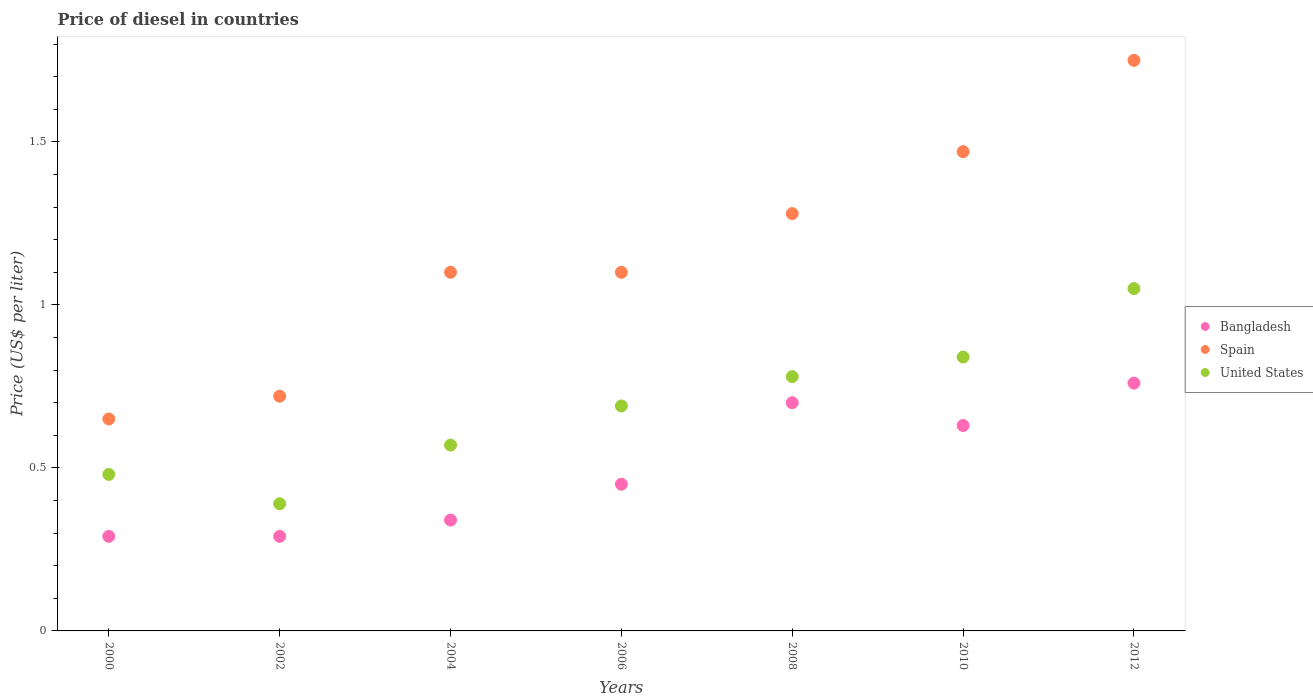What is the price of diesel in United States in 2006?
Provide a succinct answer. 0.69. Across all years, what is the maximum price of diesel in United States?
Provide a succinct answer. 1.05. Across all years, what is the minimum price of diesel in Spain?
Provide a short and direct response. 0.65. In which year was the price of diesel in United States maximum?
Give a very brief answer. 2012. In which year was the price of diesel in Bangladesh minimum?
Offer a terse response. 2000. What is the total price of diesel in Spain in the graph?
Your answer should be very brief. 8.07. What is the difference between the price of diesel in United States in 2002 and that in 2010?
Provide a succinct answer. -0.45. What is the average price of diesel in Bangladesh per year?
Provide a succinct answer. 0.49. In the year 2012, what is the difference between the price of diesel in Bangladesh and price of diesel in United States?
Your answer should be very brief. -0.29. What is the ratio of the price of diesel in Spain in 2006 to that in 2010?
Give a very brief answer. 0.75. Is the price of diesel in United States in 2004 less than that in 2006?
Make the answer very short. Yes. What is the difference between the highest and the second highest price of diesel in United States?
Give a very brief answer. 0.21. What is the difference between the highest and the lowest price of diesel in Bangladesh?
Ensure brevity in your answer.  0.47. In how many years, is the price of diesel in Spain greater than the average price of diesel in Spain taken over all years?
Provide a succinct answer. 3. Is the sum of the price of diesel in United States in 2002 and 2010 greater than the maximum price of diesel in Bangladesh across all years?
Your answer should be compact. Yes. Does the price of diesel in Spain monotonically increase over the years?
Keep it short and to the point. No. How many years are there in the graph?
Ensure brevity in your answer.  7. Are the values on the major ticks of Y-axis written in scientific E-notation?
Provide a short and direct response. No. Does the graph contain any zero values?
Provide a succinct answer. No. Where does the legend appear in the graph?
Your answer should be compact. Center right. How are the legend labels stacked?
Your response must be concise. Vertical. What is the title of the graph?
Give a very brief answer. Price of diesel in countries. Does "St. Lucia" appear as one of the legend labels in the graph?
Give a very brief answer. No. What is the label or title of the Y-axis?
Provide a short and direct response. Price (US$ per liter). What is the Price (US$ per liter) in Bangladesh in 2000?
Give a very brief answer. 0.29. What is the Price (US$ per liter) of Spain in 2000?
Your response must be concise. 0.65. What is the Price (US$ per liter) of United States in 2000?
Offer a terse response. 0.48. What is the Price (US$ per liter) of Bangladesh in 2002?
Give a very brief answer. 0.29. What is the Price (US$ per liter) in Spain in 2002?
Ensure brevity in your answer.  0.72. What is the Price (US$ per liter) of United States in 2002?
Ensure brevity in your answer.  0.39. What is the Price (US$ per liter) in Bangladesh in 2004?
Make the answer very short. 0.34. What is the Price (US$ per liter) of Spain in 2004?
Give a very brief answer. 1.1. What is the Price (US$ per liter) in United States in 2004?
Your answer should be very brief. 0.57. What is the Price (US$ per liter) of Bangladesh in 2006?
Your answer should be compact. 0.45. What is the Price (US$ per liter) of United States in 2006?
Make the answer very short. 0.69. What is the Price (US$ per liter) in Spain in 2008?
Keep it short and to the point. 1.28. What is the Price (US$ per liter) of United States in 2008?
Provide a short and direct response. 0.78. What is the Price (US$ per liter) of Bangladesh in 2010?
Offer a terse response. 0.63. What is the Price (US$ per liter) in Spain in 2010?
Make the answer very short. 1.47. What is the Price (US$ per liter) of United States in 2010?
Your answer should be very brief. 0.84. What is the Price (US$ per liter) of Bangladesh in 2012?
Keep it short and to the point. 0.76. What is the Price (US$ per liter) of Spain in 2012?
Your answer should be very brief. 1.75. Across all years, what is the maximum Price (US$ per liter) in Bangladesh?
Your answer should be very brief. 0.76. Across all years, what is the maximum Price (US$ per liter) in Spain?
Your answer should be compact. 1.75. Across all years, what is the maximum Price (US$ per liter) in United States?
Provide a succinct answer. 1.05. Across all years, what is the minimum Price (US$ per liter) in Bangladesh?
Provide a short and direct response. 0.29. Across all years, what is the minimum Price (US$ per liter) in Spain?
Offer a terse response. 0.65. Across all years, what is the minimum Price (US$ per liter) of United States?
Offer a very short reply. 0.39. What is the total Price (US$ per liter) of Bangladesh in the graph?
Your answer should be compact. 3.46. What is the total Price (US$ per liter) of Spain in the graph?
Offer a terse response. 8.07. What is the total Price (US$ per liter) in United States in the graph?
Offer a terse response. 4.8. What is the difference between the Price (US$ per liter) of Bangladesh in 2000 and that in 2002?
Provide a short and direct response. 0. What is the difference between the Price (US$ per liter) in Spain in 2000 and that in 2002?
Provide a succinct answer. -0.07. What is the difference between the Price (US$ per liter) in United States in 2000 and that in 2002?
Offer a very short reply. 0.09. What is the difference between the Price (US$ per liter) of Bangladesh in 2000 and that in 2004?
Provide a succinct answer. -0.05. What is the difference between the Price (US$ per liter) in Spain in 2000 and that in 2004?
Keep it short and to the point. -0.45. What is the difference between the Price (US$ per liter) in United States in 2000 and that in 2004?
Offer a terse response. -0.09. What is the difference between the Price (US$ per liter) of Bangladesh in 2000 and that in 2006?
Your response must be concise. -0.16. What is the difference between the Price (US$ per liter) of Spain in 2000 and that in 2006?
Your answer should be compact. -0.45. What is the difference between the Price (US$ per liter) in United States in 2000 and that in 2006?
Your answer should be compact. -0.21. What is the difference between the Price (US$ per liter) in Bangladesh in 2000 and that in 2008?
Your answer should be very brief. -0.41. What is the difference between the Price (US$ per liter) of Spain in 2000 and that in 2008?
Your answer should be compact. -0.63. What is the difference between the Price (US$ per liter) of United States in 2000 and that in 2008?
Ensure brevity in your answer.  -0.3. What is the difference between the Price (US$ per liter) of Bangladesh in 2000 and that in 2010?
Your answer should be compact. -0.34. What is the difference between the Price (US$ per liter) in Spain in 2000 and that in 2010?
Offer a terse response. -0.82. What is the difference between the Price (US$ per liter) of United States in 2000 and that in 2010?
Provide a short and direct response. -0.36. What is the difference between the Price (US$ per liter) in Bangladesh in 2000 and that in 2012?
Make the answer very short. -0.47. What is the difference between the Price (US$ per liter) of United States in 2000 and that in 2012?
Provide a short and direct response. -0.57. What is the difference between the Price (US$ per liter) in Spain in 2002 and that in 2004?
Your answer should be compact. -0.38. What is the difference between the Price (US$ per liter) in United States in 2002 and that in 2004?
Make the answer very short. -0.18. What is the difference between the Price (US$ per liter) in Bangladesh in 2002 and that in 2006?
Your answer should be compact. -0.16. What is the difference between the Price (US$ per liter) of Spain in 2002 and that in 2006?
Give a very brief answer. -0.38. What is the difference between the Price (US$ per liter) of United States in 2002 and that in 2006?
Offer a terse response. -0.3. What is the difference between the Price (US$ per liter) in Bangladesh in 2002 and that in 2008?
Your response must be concise. -0.41. What is the difference between the Price (US$ per liter) in Spain in 2002 and that in 2008?
Your answer should be very brief. -0.56. What is the difference between the Price (US$ per liter) of United States in 2002 and that in 2008?
Ensure brevity in your answer.  -0.39. What is the difference between the Price (US$ per liter) in Bangladesh in 2002 and that in 2010?
Provide a short and direct response. -0.34. What is the difference between the Price (US$ per liter) in Spain in 2002 and that in 2010?
Your answer should be very brief. -0.75. What is the difference between the Price (US$ per liter) in United States in 2002 and that in 2010?
Your answer should be compact. -0.45. What is the difference between the Price (US$ per liter) of Bangladesh in 2002 and that in 2012?
Ensure brevity in your answer.  -0.47. What is the difference between the Price (US$ per liter) of Spain in 2002 and that in 2012?
Offer a terse response. -1.03. What is the difference between the Price (US$ per liter) of United States in 2002 and that in 2012?
Your answer should be compact. -0.66. What is the difference between the Price (US$ per liter) of Bangladesh in 2004 and that in 2006?
Your answer should be compact. -0.11. What is the difference between the Price (US$ per liter) in Spain in 2004 and that in 2006?
Your response must be concise. 0. What is the difference between the Price (US$ per liter) in United States in 2004 and that in 2006?
Provide a succinct answer. -0.12. What is the difference between the Price (US$ per liter) of Bangladesh in 2004 and that in 2008?
Your response must be concise. -0.36. What is the difference between the Price (US$ per liter) in Spain in 2004 and that in 2008?
Offer a terse response. -0.18. What is the difference between the Price (US$ per liter) of United States in 2004 and that in 2008?
Provide a short and direct response. -0.21. What is the difference between the Price (US$ per liter) of Bangladesh in 2004 and that in 2010?
Offer a very short reply. -0.29. What is the difference between the Price (US$ per liter) of Spain in 2004 and that in 2010?
Ensure brevity in your answer.  -0.37. What is the difference between the Price (US$ per liter) in United States in 2004 and that in 2010?
Ensure brevity in your answer.  -0.27. What is the difference between the Price (US$ per liter) of Bangladesh in 2004 and that in 2012?
Your response must be concise. -0.42. What is the difference between the Price (US$ per liter) of Spain in 2004 and that in 2012?
Offer a terse response. -0.65. What is the difference between the Price (US$ per liter) in United States in 2004 and that in 2012?
Keep it short and to the point. -0.48. What is the difference between the Price (US$ per liter) of Spain in 2006 and that in 2008?
Your answer should be very brief. -0.18. What is the difference between the Price (US$ per liter) of United States in 2006 and that in 2008?
Keep it short and to the point. -0.09. What is the difference between the Price (US$ per liter) in Bangladesh in 2006 and that in 2010?
Ensure brevity in your answer.  -0.18. What is the difference between the Price (US$ per liter) in Spain in 2006 and that in 2010?
Provide a succinct answer. -0.37. What is the difference between the Price (US$ per liter) in United States in 2006 and that in 2010?
Keep it short and to the point. -0.15. What is the difference between the Price (US$ per liter) of Bangladesh in 2006 and that in 2012?
Provide a short and direct response. -0.31. What is the difference between the Price (US$ per liter) of Spain in 2006 and that in 2012?
Provide a succinct answer. -0.65. What is the difference between the Price (US$ per liter) in United States in 2006 and that in 2012?
Provide a short and direct response. -0.36. What is the difference between the Price (US$ per liter) of Bangladesh in 2008 and that in 2010?
Offer a terse response. 0.07. What is the difference between the Price (US$ per liter) in Spain in 2008 and that in 2010?
Give a very brief answer. -0.19. What is the difference between the Price (US$ per liter) of United States in 2008 and that in 2010?
Provide a succinct answer. -0.06. What is the difference between the Price (US$ per liter) of Bangladesh in 2008 and that in 2012?
Your answer should be compact. -0.06. What is the difference between the Price (US$ per liter) in Spain in 2008 and that in 2012?
Your answer should be compact. -0.47. What is the difference between the Price (US$ per liter) of United States in 2008 and that in 2012?
Make the answer very short. -0.27. What is the difference between the Price (US$ per liter) in Bangladesh in 2010 and that in 2012?
Offer a terse response. -0.13. What is the difference between the Price (US$ per liter) in Spain in 2010 and that in 2012?
Provide a short and direct response. -0.28. What is the difference between the Price (US$ per liter) of United States in 2010 and that in 2012?
Give a very brief answer. -0.21. What is the difference between the Price (US$ per liter) in Bangladesh in 2000 and the Price (US$ per liter) in Spain in 2002?
Keep it short and to the point. -0.43. What is the difference between the Price (US$ per liter) in Spain in 2000 and the Price (US$ per liter) in United States in 2002?
Ensure brevity in your answer.  0.26. What is the difference between the Price (US$ per liter) in Bangladesh in 2000 and the Price (US$ per liter) in Spain in 2004?
Provide a succinct answer. -0.81. What is the difference between the Price (US$ per liter) of Bangladesh in 2000 and the Price (US$ per liter) of United States in 2004?
Give a very brief answer. -0.28. What is the difference between the Price (US$ per liter) in Bangladesh in 2000 and the Price (US$ per liter) in Spain in 2006?
Give a very brief answer. -0.81. What is the difference between the Price (US$ per liter) of Bangladesh in 2000 and the Price (US$ per liter) of United States in 2006?
Your answer should be compact. -0.4. What is the difference between the Price (US$ per liter) of Spain in 2000 and the Price (US$ per liter) of United States in 2006?
Make the answer very short. -0.04. What is the difference between the Price (US$ per liter) in Bangladesh in 2000 and the Price (US$ per liter) in Spain in 2008?
Your answer should be compact. -0.99. What is the difference between the Price (US$ per liter) in Bangladesh in 2000 and the Price (US$ per liter) in United States in 2008?
Offer a very short reply. -0.49. What is the difference between the Price (US$ per liter) of Spain in 2000 and the Price (US$ per liter) of United States in 2008?
Your response must be concise. -0.13. What is the difference between the Price (US$ per liter) in Bangladesh in 2000 and the Price (US$ per liter) in Spain in 2010?
Provide a short and direct response. -1.18. What is the difference between the Price (US$ per liter) in Bangladesh in 2000 and the Price (US$ per liter) in United States in 2010?
Make the answer very short. -0.55. What is the difference between the Price (US$ per liter) of Spain in 2000 and the Price (US$ per liter) of United States in 2010?
Make the answer very short. -0.19. What is the difference between the Price (US$ per liter) in Bangladesh in 2000 and the Price (US$ per liter) in Spain in 2012?
Your answer should be very brief. -1.46. What is the difference between the Price (US$ per liter) of Bangladesh in 2000 and the Price (US$ per liter) of United States in 2012?
Make the answer very short. -0.76. What is the difference between the Price (US$ per liter) of Spain in 2000 and the Price (US$ per liter) of United States in 2012?
Your answer should be compact. -0.4. What is the difference between the Price (US$ per liter) in Bangladesh in 2002 and the Price (US$ per liter) in Spain in 2004?
Ensure brevity in your answer.  -0.81. What is the difference between the Price (US$ per liter) in Bangladesh in 2002 and the Price (US$ per liter) in United States in 2004?
Offer a terse response. -0.28. What is the difference between the Price (US$ per liter) in Bangladesh in 2002 and the Price (US$ per liter) in Spain in 2006?
Provide a short and direct response. -0.81. What is the difference between the Price (US$ per liter) in Bangladesh in 2002 and the Price (US$ per liter) in Spain in 2008?
Provide a succinct answer. -0.99. What is the difference between the Price (US$ per liter) of Bangladesh in 2002 and the Price (US$ per liter) of United States in 2008?
Provide a short and direct response. -0.49. What is the difference between the Price (US$ per liter) of Spain in 2002 and the Price (US$ per liter) of United States in 2008?
Your answer should be very brief. -0.06. What is the difference between the Price (US$ per liter) of Bangladesh in 2002 and the Price (US$ per liter) of Spain in 2010?
Keep it short and to the point. -1.18. What is the difference between the Price (US$ per liter) in Bangladesh in 2002 and the Price (US$ per liter) in United States in 2010?
Provide a short and direct response. -0.55. What is the difference between the Price (US$ per liter) in Spain in 2002 and the Price (US$ per liter) in United States in 2010?
Give a very brief answer. -0.12. What is the difference between the Price (US$ per liter) in Bangladesh in 2002 and the Price (US$ per liter) in Spain in 2012?
Ensure brevity in your answer.  -1.46. What is the difference between the Price (US$ per liter) of Bangladesh in 2002 and the Price (US$ per liter) of United States in 2012?
Make the answer very short. -0.76. What is the difference between the Price (US$ per liter) in Spain in 2002 and the Price (US$ per liter) in United States in 2012?
Offer a terse response. -0.33. What is the difference between the Price (US$ per liter) in Bangladesh in 2004 and the Price (US$ per liter) in Spain in 2006?
Your answer should be very brief. -0.76. What is the difference between the Price (US$ per liter) in Bangladesh in 2004 and the Price (US$ per liter) in United States in 2006?
Give a very brief answer. -0.35. What is the difference between the Price (US$ per liter) in Spain in 2004 and the Price (US$ per liter) in United States in 2006?
Keep it short and to the point. 0.41. What is the difference between the Price (US$ per liter) in Bangladesh in 2004 and the Price (US$ per liter) in Spain in 2008?
Keep it short and to the point. -0.94. What is the difference between the Price (US$ per liter) in Bangladesh in 2004 and the Price (US$ per liter) in United States in 2008?
Provide a short and direct response. -0.44. What is the difference between the Price (US$ per liter) in Spain in 2004 and the Price (US$ per liter) in United States in 2008?
Provide a succinct answer. 0.32. What is the difference between the Price (US$ per liter) of Bangladesh in 2004 and the Price (US$ per liter) of Spain in 2010?
Give a very brief answer. -1.13. What is the difference between the Price (US$ per liter) of Bangladesh in 2004 and the Price (US$ per liter) of United States in 2010?
Offer a very short reply. -0.5. What is the difference between the Price (US$ per liter) in Spain in 2004 and the Price (US$ per liter) in United States in 2010?
Your answer should be very brief. 0.26. What is the difference between the Price (US$ per liter) in Bangladesh in 2004 and the Price (US$ per liter) in Spain in 2012?
Ensure brevity in your answer.  -1.41. What is the difference between the Price (US$ per liter) in Bangladesh in 2004 and the Price (US$ per liter) in United States in 2012?
Keep it short and to the point. -0.71. What is the difference between the Price (US$ per liter) in Bangladesh in 2006 and the Price (US$ per liter) in Spain in 2008?
Offer a terse response. -0.83. What is the difference between the Price (US$ per liter) in Bangladesh in 2006 and the Price (US$ per liter) in United States in 2008?
Provide a succinct answer. -0.33. What is the difference between the Price (US$ per liter) of Spain in 2006 and the Price (US$ per liter) of United States in 2008?
Make the answer very short. 0.32. What is the difference between the Price (US$ per liter) of Bangladesh in 2006 and the Price (US$ per liter) of Spain in 2010?
Provide a succinct answer. -1.02. What is the difference between the Price (US$ per liter) in Bangladesh in 2006 and the Price (US$ per liter) in United States in 2010?
Your answer should be compact. -0.39. What is the difference between the Price (US$ per liter) of Spain in 2006 and the Price (US$ per liter) of United States in 2010?
Your answer should be compact. 0.26. What is the difference between the Price (US$ per liter) in Bangladesh in 2006 and the Price (US$ per liter) in United States in 2012?
Your answer should be compact. -0.6. What is the difference between the Price (US$ per liter) of Spain in 2006 and the Price (US$ per liter) of United States in 2012?
Provide a short and direct response. 0.05. What is the difference between the Price (US$ per liter) in Bangladesh in 2008 and the Price (US$ per liter) in Spain in 2010?
Offer a terse response. -0.77. What is the difference between the Price (US$ per liter) in Bangladesh in 2008 and the Price (US$ per liter) in United States in 2010?
Offer a very short reply. -0.14. What is the difference between the Price (US$ per liter) of Spain in 2008 and the Price (US$ per liter) of United States in 2010?
Make the answer very short. 0.44. What is the difference between the Price (US$ per liter) of Bangladesh in 2008 and the Price (US$ per liter) of Spain in 2012?
Make the answer very short. -1.05. What is the difference between the Price (US$ per liter) of Bangladesh in 2008 and the Price (US$ per liter) of United States in 2012?
Make the answer very short. -0.35. What is the difference between the Price (US$ per liter) of Spain in 2008 and the Price (US$ per liter) of United States in 2012?
Make the answer very short. 0.23. What is the difference between the Price (US$ per liter) in Bangladesh in 2010 and the Price (US$ per liter) in Spain in 2012?
Ensure brevity in your answer.  -1.12. What is the difference between the Price (US$ per liter) in Bangladesh in 2010 and the Price (US$ per liter) in United States in 2012?
Make the answer very short. -0.42. What is the difference between the Price (US$ per liter) in Spain in 2010 and the Price (US$ per liter) in United States in 2012?
Provide a succinct answer. 0.42. What is the average Price (US$ per liter) of Bangladesh per year?
Make the answer very short. 0.49. What is the average Price (US$ per liter) of Spain per year?
Your answer should be very brief. 1.15. What is the average Price (US$ per liter) in United States per year?
Provide a succinct answer. 0.69. In the year 2000, what is the difference between the Price (US$ per liter) in Bangladesh and Price (US$ per liter) in Spain?
Keep it short and to the point. -0.36. In the year 2000, what is the difference between the Price (US$ per liter) of Bangladesh and Price (US$ per liter) of United States?
Offer a very short reply. -0.19. In the year 2000, what is the difference between the Price (US$ per liter) of Spain and Price (US$ per liter) of United States?
Ensure brevity in your answer.  0.17. In the year 2002, what is the difference between the Price (US$ per liter) in Bangladesh and Price (US$ per liter) in Spain?
Keep it short and to the point. -0.43. In the year 2002, what is the difference between the Price (US$ per liter) of Spain and Price (US$ per liter) of United States?
Make the answer very short. 0.33. In the year 2004, what is the difference between the Price (US$ per liter) of Bangladesh and Price (US$ per liter) of Spain?
Your answer should be compact. -0.76. In the year 2004, what is the difference between the Price (US$ per liter) of Bangladesh and Price (US$ per liter) of United States?
Offer a terse response. -0.23. In the year 2004, what is the difference between the Price (US$ per liter) in Spain and Price (US$ per liter) in United States?
Give a very brief answer. 0.53. In the year 2006, what is the difference between the Price (US$ per liter) in Bangladesh and Price (US$ per liter) in Spain?
Make the answer very short. -0.65. In the year 2006, what is the difference between the Price (US$ per liter) of Bangladesh and Price (US$ per liter) of United States?
Offer a very short reply. -0.24. In the year 2006, what is the difference between the Price (US$ per liter) of Spain and Price (US$ per liter) of United States?
Provide a succinct answer. 0.41. In the year 2008, what is the difference between the Price (US$ per liter) in Bangladesh and Price (US$ per liter) in Spain?
Offer a very short reply. -0.58. In the year 2008, what is the difference between the Price (US$ per liter) of Bangladesh and Price (US$ per liter) of United States?
Provide a succinct answer. -0.08. In the year 2010, what is the difference between the Price (US$ per liter) in Bangladesh and Price (US$ per liter) in Spain?
Your answer should be compact. -0.84. In the year 2010, what is the difference between the Price (US$ per liter) in Bangladesh and Price (US$ per liter) in United States?
Ensure brevity in your answer.  -0.21. In the year 2010, what is the difference between the Price (US$ per liter) of Spain and Price (US$ per liter) of United States?
Offer a very short reply. 0.63. In the year 2012, what is the difference between the Price (US$ per liter) in Bangladesh and Price (US$ per liter) in Spain?
Provide a short and direct response. -0.99. In the year 2012, what is the difference between the Price (US$ per liter) in Bangladesh and Price (US$ per liter) in United States?
Your answer should be compact. -0.29. What is the ratio of the Price (US$ per liter) in Bangladesh in 2000 to that in 2002?
Provide a short and direct response. 1. What is the ratio of the Price (US$ per liter) of Spain in 2000 to that in 2002?
Give a very brief answer. 0.9. What is the ratio of the Price (US$ per liter) in United States in 2000 to that in 2002?
Offer a terse response. 1.23. What is the ratio of the Price (US$ per liter) of Bangladesh in 2000 to that in 2004?
Ensure brevity in your answer.  0.85. What is the ratio of the Price (US$ per liter) of Spain in 2000 to that in 2004?
Ensure brevity in your answer.  0.59. What is the ratio of the Price (US$ per liter) in United States in 2000 to that in 2004?
Make the answer very short. 0.84. What is the ratio of the Price (US$ per liter) of Bangladesh in 2000 to that in 2006?
Offer a terse response. 0.64. What is the ratio of the Price (US$ per liter) in Spain in 2000 to that in 2006?
Provide a short and direct response. 0.59. What is the ratio of the Price (US$ per liter) of United States in 2000 to that in 2006?
Your answer should be very brief. 0.7. What is the ratio of the Price (US$ per liter) in Bangladesh in 2000 to that in 2008?
Your response must be concise. 0.41. What is the ratio of the Price (US$ per liter) of Spain in 2000 to that in 2008?
Keep it short and to the point. 0.51. What is the ratio of the Price (US$ per liter) of United States in 2000 to that in 2008?
Your answer should be compact. 0.62. What is the ratio of the Price (US$ per liter) of Bangladesh in 2000 to that in 2010?
Provide a succinct answer. 0.46. What is the ratio of the Price (US$ per liter) of Spain in 2000 to that in 2010?
Provide a succinct answer. 0.44. What is the ratio of the Price (US$ per liter) in United States in 2000 to that in 2010?
Your answer should be compact. 0.57. What is the ratio of the Price (US$ per liter) of Bangladesh in 2000 to that in 2012?
Keep it short and to the point. 0.38. What is the ratio of the Price (US$ per liter) of Spain in 2000 to that in 2012?
Make the answer very short. 0.37. What is the ratio of the Price (US$ per liter) of United States in 2000 to that in 2012?
Ensure brevity in your answer.  0.46. What is the ratio of the Price (US$ per liter) of Bangladesh in 2002 to that in 2004?
Offer a terse response. 0.85. What is the ratio of the Price (US$ per liter) of Spain in 2002 to that in 2004?
Your answer should be very brief. 0.65. What is the ratio of the Price (US$ per liter) of United States in 2002 to that in 2004?
Ensure brevity in your answer.  0.68. What is the ratio of the Price (US$ per liter) in Bangladesh in 2002 to that in 2006?
Your answer should be compact. 0.64. What is the ratio of the Price (US$ per liter) of Spain in 2002 to that in 2006?
Make the answer very short. 0.65. What is the ratio of the Price (US$ per liter) of United States in 2002 to that in 2006?
Offer a very short reply. 0.57. What is the ratio of the Price (US$ per liter) of Bangladesh in 2002 to that in 2008?
Offer a terse response. 0.41. What is the ratio of the Price (US$ per liter) of Spain in 2002 to that in 2008?
Provide a short and direct response. 0.56. What is the ratio of the Price (US$ per liter) in United States in 2002 to that in 2008?
Your answer should be compact. 0.5. What is the ratio of the Price (US$ per liter) of Bangladesh in 2002 to that in 2010?
Your answer should be compact. 0.46. What is the ratio of the Price (US$ per liter) in Spain in 2002 to that in 2010?
Ensure brevity in your answer.  0.49. What is the ratio of the Price (US$ per liter) in United States in 2002 to that in 2010?
Provide a short and direct response. 0.46. What is the ratio of the Price (US$ per liter) of Bangladesh in 2002 to that in 2012?
Keep it short and to the point. 0.38. What is the ratio of the Price (US$ per liter) of Spain in 2002 to that in 2012?
Provide a short and direct response. 0.41. What is the ratio of the Price (US$ per liter) in United States in 2002 to that in 2012?
Provide a short and direct response. 0.37. What is the ratio of the Price (US$ per liter) in Bangladesh in 2004 to that in 2006?
Offer a very short reply. 0.76. What is the ratio of the Price (US$ per liter) in Spain in 2004 to that in 2006?
Provide a short and direct response. 1. What is the ratio of the Price (US$ per liter) in United States in 2004 to that in 2006?
Keep it short and to the point. 0.83. What is the ratio of the Price (US$ per liter) of Bangladesh in 2004 to that in 2008?
Make the answer very short. 0.49. What is the ratio of the Price (US$ per liter) in Spain in 2004 to that in 2008?
Give a very brief answer. 0.86. What is the ratio of the Price (US$ per liter) of United States in 2004 to that in 2008?
Make the answer very short. 0.73. What is the ratio of the Price (US$ per liter) of Bangladesh in 2004 to that in 2010?
Provide a succinct answer. 0.54. What is the ratio of the Price (US$ per liter) of Spain in 2004 to that in 2010?
Make the answer very short. 0.75. What is the ratio of the Price (US$ per liter) of United States in 2004 to that in 2010?
Provide a short and direct response. 0.68. What is the ratio of the Price (US$ per liter) in Bangladesh in 2004 to that in 2012?
Keep it short and to the point. 0.45. What is the ratio of the Price (US$ per liter) in Spain in 2004 to that in 2012?
Provide a short and direct response. 0.63. What is the ratio of the Price (US$ per liter) in United States in 2004 to that in 2012?
Offer a very short reply. 0.54. What is the ratio of the Price (US$ per liter) in Bangladesh in 2006 to that in 2008?
Make the answer very short. 0.64. What is the ratio of the Price (US$ per liter) in Spain in 2006 to that in 2008?
Your response must be concise. 0.86. What is the ratio of the Price (US$ per liter) in United States in 2006 to that in 2008?
Provide a succinct answer. 0.88. What is the ratio of the Price (US$ per liter) in Bangladesh in 2006 to that in 2010?
Your answer should be compact. 0.71. What is the ratio of the Price (US$ per liter) of Spain in 2006 to that in 2010?
Provide a short and direct response. 0.75. What is the ratio of the Price (US$ per liter) of United States in 2006 to that in 2010?
Your answer should be very brief. 0.82. What is the ratio of the Price (US$ per liter) of Bangladesh in 2006 to that in 2012?
Keep it short and to the point. 0.59. What is the ratio of the Price (US$ per liter) of Spain in 2006 to that in 2012?
Keep it short and to the point. 0.63. What is the ratio of the Price (US$ per liter) in United States in 2006 to that in 2012?
Your answer should be compact. 0.66. What is the ratio of the Price (US$ per liter) in Spain in 2008 to that in 2010?
Your response must be concise. 0.87. What is the ratio of the Price (US$ per liter) in United States in 2008 to that in 2010?
Offer a very short reply. 0.93. What is the ratio of the Price (US$ per liter) of Bangladesh in 2008 to that in 2012?
Your answer should be very brief. 0.92. What is the ratio of the Price (US$ per liter) in Spain in 2008 to that in 2012?
Keep it short and to the point. 0.73. What is the ratio of the Price (US$ per liter) of United States in 2008 to that in 2012?
Offer a very short reply. 0.74. What is the ratio of the Price (US$ per liter) in Bangladesh in 2010 to that in 2012?
Offer a terse response. 0.83. What is the ratio of the Price (US$ per liter) of Spain in 2010 to that in 2012?
Your answer should be very brief. 0.84. What is the difference between the highest and the second highest Price (US$ per liter) in Spain?
Your answer should be compact. 0.28. What is the difference between the highest and the second highest Price (US$ per liter) in United States?
Your answer should be compact. 0.21. What is the difference between the highest and the lowest Price (US$ per liter) of Bangladesh?
Offer a very short reply. 0.47. What is the difference between the highest and the lowest Price (US$ per liter) of United States?
Provide a succinct answer. 0.66. 